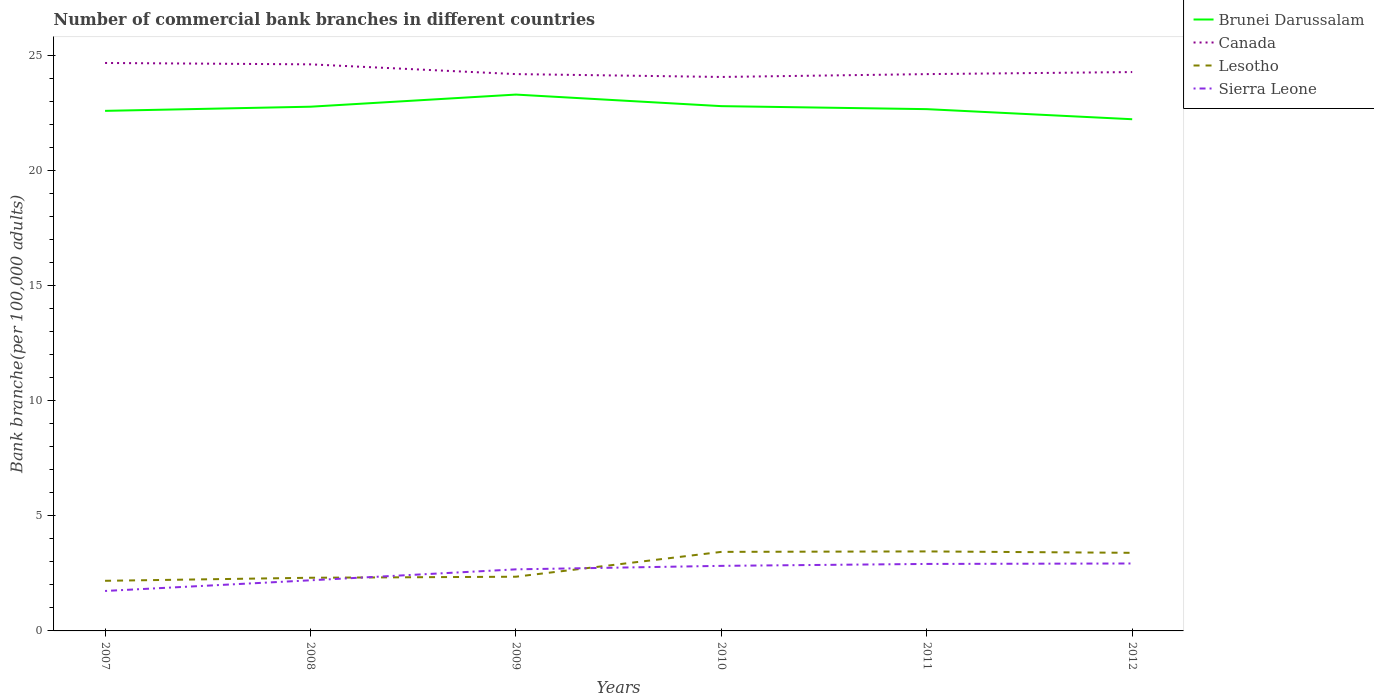Does the line corresponding to Canada intersect with the line corresponding to Sierra Leone?
Your response must be concise. No. Across all years, what is the maximum number of commercial bank branches in Lesotho?
Ensure brevity in your answer.  2.18. What is the total number of commercial bank branches in Canada in the graph?
Your answer should be compact. 0.48. What is the difference between the highest and the second highest number of commercial bank branches in Lesotho?
Provide a short and direct response. 1.28. What is the difference between the highest and the lowest number of commercial bank branches in Sierra Leone?
Offer a terse response. 4. Is the number of commercial bank branches in Sierra Leone strictly greater than the number of commercial bank branches in Canada over the years?
Keep it short and to the point. Yes. How many lines are there?
Offer a very short reply. 4. Does the graph contain grids?
Ensure brevity in your answer.  No. How many legend labels are there?
Provide a short and direct response. 4. What is the title of the graph?
Your answer should be very brief. Number of commercial bank branches in different countries. What is the label or title of the Y-axis?
Keep it short and to the point. Bank branche(per 100,0 adults). What is the Bank branche(per 100,000 adults) of Brunei Darussalam in 2007?
Your response must be concise. 22.58. What is the Bank branche(per 100,000 adults) of Canada in 2007?
Provide a short and direct response. 24.66. What is the Bank branche(per 100,000 adults) in Lesotho in 2007?
Offer a very short reply. 2.18. What is the Bank branche(per 100,000 adults) of Sierra Leone in 2007?
Ensure brevity in your answer.  1.73. What is the Bank branche(per 100,000 adults) in Brunei Darussalam in 2008?
Provide a succinct answer. 22.76. What is the Bank branche(per 100,000 adults) of Canada in 2008?
Your answer should be compact. 24.6. What is the Bank branche(per 100,000 adults) in Lesotho in 2008?
Provide a succinct answer. 2.31. What is the Bank branche(per 100,000 adults) of Sierra Leone in 2008?
Keep it short and to the point. 2.2. What is the Bank branche(per 100,000 adults) of Brunei Darussalam in 2009?
Make the answer very short. 23.29. What is the Bank branche(per 100,000 adults) of Canada in 2009?
Your answer should be compact. 24.18. What is the Bank branche(per 100,000 adults) in Lesotho in 2009?
Offer a very short reply. 2.35. What is the Bank branche(per 100,000 adults) in Sierra Leone in 2009?
Make the answer very short. 2.67. What is the Bank branche(per 100,000 adults) in Brunei Darussalam in 2010?
Keep it short and to the point. 22.79. What is the Bank branche(per 100,000 adults) in Canada in 2010?
Provide a short and direct response. 24.05. What is the Bank branche(per 100,000 adults) in Lesotho in 2010?
Your response must be concise. 3.43. What is the Bank branche(per 100,000 adults) of Sierra Leone in 2010?
Offer a very short reply. 2.83. What is the Bank branche(per 100,000 adults) of Brunei Darussalam in 2011?
Keep it short and to the point. 22.66. What is the Bank branche(per 100,000 adults) in Canada in 2011?
Your answer should be compact. 24.18. What is the Bank branche(per 100,000 adults) in Lesotho in 2011?
Your answer should be very brief. 3.45. What is the Bank branche(per 100,000 adults) in Sierra Leone in 2011?
Provide a short and direct response. 2.91. What is the Bank branche(per 100,000 adults) of Brunei Darussalam in 2012?
Your answer should be compact. 22.22. What is the Bank branche(per 100,000 adults) of Canada in 2012?
Provide a short and direct response. 24.27. What is the Bank branche(per 100,000 adults) of Lesotho in 2012?
Ensure brevity in your answer.  3.39. What is the Bank branche(per 100,000 adults) of Sierra Leone in 2012?
Keep it short and to the point. 2.93. Across all years, what is the maximum Bank branche(per 100,000 adults) in Brunei Darussalam?
Your answer should be compact. 23.29. Across all years, what is the maximum Bank branche(per 100,000 adults) in Canada?
Provide a short and direct response. 24.66. Across all years, what is the maximum Bank branche(per 100,000 adults) in Lesotho?
Your answer should be very brief. 3.45. Across all years, what is the maximum Bank branche(per 100,000 adults) in Sierra Leone?
Your answer should be compact. 2.93. Across all years, what is the minimum Bank branche(per 100,000 adults) in Brunei Darussalam?
Offer a very short reply. 22.22. Across all years, what is the minimum Bank branche(per 100,000 adults) in Canada?
Give a very brief answer. 24.05. Across all years, what is the minimum Bank branche(per 100,000 adults) of Lesotho?
Provide a succinct answer. 2.18. Across all years, what is the minimum Bank branche(per 100,000 adults) in Sierra Leone?
Offer a terse response. 1.73. What is the total Bank branche(per 100,000 adults) of Brunei Darussalam in the graph?
Ensure brevity in your answer.  136.29. What is the total Bank branche(per 100,000 adults) in Canada in the graph?
Your answer should be very brief. 145.93. What is the total Bank branche(per 100,000 adults) in Lesotho in the graph?
Offer a very short reply. 17.11. What is the total Bank branche(per 100,000 adults) of Sierra Leone in the graph?
Keep it short and to the point. 15.27. What is the difference between the Bank branche(per 100,000 adults) in Brunei Darussalam in 2007 and that in 2008?
Offer a terse response. -0.18. What is the difference between the Bank branche(per 100,000 adults) in Canada in 2007 and that in 2008?
Keep it short and to the point. 0.06. What is the difference between the Bank branche(per 100,000 adults) of Lesotho in 2007 and that in 2008?
Provide a short and direct response. -0.13. What is the difference between the Bank branche(per 100,000 adults) in Sierra Leone in 2007 and that in 2008?
Offer a terse response. -0.46. What is the difference between the Bank branche(per 100,000 adults) in Brunei Darussalam in 2007 and that in 2009?
Give a very brief answer. -0.71. What is the difference between the Bank branche(per 100,000 adults) in Canada in 2007 and that in 2009?
Provide a succinct answer. 0.48. What is the difference between the Bank branche(per 100,000 adults) in Lesotho in 2007 and that in 2009?
Offer a very short reply. -0.18. What is the difference between the Bank branche(per 100,000 adults) in Sierra Leone in 2007 and that in 2009?
Make the answer very short. -0.94. What is the difference between the Bank branche(per 100,000 adults) in Brunei Darussalam in 2007 and that in 2010?
Offer a very short reply. -0.2. What is the difference between the Bank branche(per 100,000 adults) of Canada in 2007 and that in 2010?
Offer a terse response. 0.61. What is the difference between the Bank branche(per 100,000 adults) of Lesotho in 2007 and that in 2010?
Offer a very short reply. -1.26. What is the difference between the Bank branche(per 100,000 adults) of Sierra Leone in 2007 and that in 2010?
Provide a short and direct response. -1.09. What is the difference between the Bank branche(per 100,000 adults) in Brunei Darussalam in 2007 and that in 2011?
Your answer should be very brief. -0.07. What is the difference between the Bank branche(per 100,000 adults) in Canada in 2007 and that in 2011?
Keep it short and to the point. 0.48. What is the difference between the Bank branche(per 100,000 adults) of Lesotho in 2007 and that in 2011?
Your answer should be compact. -1.28. What is the difference between the Bank branche(per 100,000 adults) of Sierra Leone in 2007 and that in 2011?
Your answer should be compact. -1.17. What is the difference between the Bank branche(per 100,000 adults) in Brunei Darussalam in 2007 and that in 2012?
Offer a very short reply. 0.36. What is the difference between the Bank branche(per 100,000 adults) of Canada in 2007 and that in 2012?
Give a very brief answer. 0.39. What is the difference between the Bank branche(per 100,000 adults) of Lesotho in 2007 and that in 2012?
Keep it short and to the point. -1.21. What is the difference between the Bank branche(per 100,000 adults) of Sierra Leone in 2007 and that in 2012?
Give a very brief answer. -1.19. What is the difference between the Bank branche(per 100,000 adults) in Brunei Darussalam in 2008 and that in 2009?
Ensure brevity in your answer.  -0.53. What is the difference between the Bank branche(per 100,000 adults) in Canada in 2008 and that in 2009?
Provide a short and direct response. 0.42. What is the difference between the Bank branche(per 100,000 adults) in Lesotho in 2008 and that in 2009?
Ensure brevity in your answer.  -0.04. What is the difference between the Bank branche(per 100,000 adults) of Sierra Leone in 2008 and that in 2009?
Provide a short and direct response. -0.48. What is the difference between the Bank branche(per 100,000 adults) of Brunei Darussalam in 2008 and that in 2010?
Your answer should be compact. -0.02. What is the difference between the Bank branche(per 100,000 adults) in Canada in 2008 and that in 2010?
Offer a very short reply. 0.55. What is the difference between the Bank branche(per 100,000 adults) of Lesotho in 2008 and that in 2010?
Provide a short and direct response. -1.12. What is the difference between the Bank branche(per 100,000 adults) of Sierra Leone in 2008 and that in 2010?
Provide a succinct answer. -0.63. What is the difference between the Bank branche(per 100,000 adults) of Brunei Darussalam in 2008 and that in 2011?
Provide a succinct answer. 0.11. What is the difference between the Bank branche(per 100,000 adults) of Canada in 2008 and that in 2011?
Provide a succinct answer. 0.42. What is the difference between the Bank branche(per 100,000 adults) in Lesotho in 2008 and that in 2011?
Your answer should be compact. -1.14. What is the difference between the Bank branche(per 100,000 adults) of Sierra Leone in 2008 and that in 2011?
Provide a succinct answer. -0.71. What is the difference between the Bank branche(per 100,000 adults) of Brunei Darussalam in 2008 and that in 2012?
Make the answer very short. 0.54. What is the difference between the Bank branche(per 100,000 adults) of Canada in 2008 and that in 2012?
Provide a short and direct response. 0.34. What is the difference between the Bank branche(per 100,000 adults) of Lesotho in 2008 and that in 2012?
Ensure brevity in your answer.  -1.08. What is the difference between the Bank branche(per 100,000 adults) in Sierra Leone in 2008 and that in 2012?
Offer a terse response. -0.73. What is the difference between the Bank branche(per 100,000 adults) in Brunei Darussalam in 2009 and that in 2010?
Your answer should be compact. 0.5. What is the difference between the Bank branche(per 100,000 adults) in Canada in 2009 and that in 2010?
Keep it short and to the point. 0.12. What is the difference between the Bank branche(per 100,000 adults) in Lesotho in 2009 and that in 2010?
Ensure brevity in your answer.  -1.08. What is the difference between the Bank branche(per 100,000 adults) in Sierra Leone in 2009 and that in 2010?
Give a very brief answer. -0.15. What is the difference between the Bank branche(per 100,000 adults) in Brunei Darussalam in 2009 and that in 2011?
Your answer should be compact. 0.63. What is the difference between the Bank branche(per 100,000 adults) of Lesotho in 2009 and that in 2011?
Keep it short and to the point. -1.1. What is the difference between the Bank branche(per 100,000 adults) in Sierra Leone in 2009 and that in 2011?
Your response must be concise. -0.23. What is the difference between the Bank branche(per 100,000 adults) in Brunei Darussalam in 2009 and that in 2012?
Your response must be concise. 1.07. What is the difference between the Bank branche(per 100,000 adults) of Canada in 2009 and that in 2012?
Make the answer very short. -0.09. What is the difference between the Bank branche(per 100,000 adults) in Lesotho in 2009 and that in 2012?
Provide a short and direct response. -1.04. What is the difference between the Bank branche(per 100,000 adults) of Sierra Leone in 2009 and that in 2012?
Make the answer very short. -0.25. What is the difference between the Bank branche(per 100,000 adults) of Brunei Darussalam in 2010 and that in 2011?
Your response must be concise. 0.13. What is the difference between the Bank branche(per 100,000 adults) in Canada in 2010 and that in 2011?
Give a very brief answer. -0.12. What is the difference between the Bank branche(per 100,000 adults) of Lesotho in 2010 and that in 2011?
Provide a short and direct response. -0.02. What is the difference between the Bank branche(per 100,000 adults) of Sierra Leone in 2010 and that in 2011?
Keep it short and to the point. -0.08. What is the difference between the Bank branche(per 100,000 adults) of Brunei Darussalam in 2010 and that in 2012?
Your answer should be very brief. 0.57. What is the difference between the Bank branche(per 100,000 adults) of Canada in 2010 and that in 2012?
Ensure brevity in your answer.  -0.21. What is the difference between the Bank branche(per 100,000 adults) of Lesotho in 2010 and that in 2012?
Provide a succinct answer. 0.04. What is the difference between the Bank branche(per 100,000 adults) in Sierra Leone in 2010 and that in 2012?
Provide a succinct answer. -0.1. What is the difference between the Bank branche(per 100,000 adults) of Brunei Darussalam in 2011 and that in 2012?
Your answer should be very brief. 0.44. What is the difference between the Bank branche(per 100,000 adults) in Canada in 2011 and that in 2012?
Keep it short and to the point. -0.09. What is the difference between the Bank branche(per 100,000 adults) of Lesotho in 2011 and that in 2012?
Provide a short and direct response. 0.06. What is the difference between the Bank branche(per 100,000 adults) of Sierra Leone in 2011 and that in 2012?
Your response must be concise. -0.02. What is the difference between the Bank branche(per 100,000 adults) in Brunei Darussalam in 2007 and the Bank branche(per 100,000 adults) in Canada in 2008?
Your response must be concise. -2.02. What is the difference between the Bank branche(per 100,000 adults) in Brunei Darussalam in 2007 and the Bank branche(per 100,000 adults) in Lesotho in 2008?
Offer a very short reply. 20.27. What is the difference between the Bank branche(per 100,000 adults) in Brunei Darussalam in 2007 and the Bank branche(per 100,000 adults) in Sierra Leone in 2008?
Offer a terse response. 20.38. What is the difference between the Bank branche(per 100,000 adults) in Canada in 2007 and the Bank branche(per 100,000 adults) in Lesotho in 2008?
Make the answer very short. 22.35. What is the difference between the Bank branche(per 100,000 adults) of Canada in 2007 and the Bank branche(per 100,000 adults) of Sierra Leone in 2008?
Your answer should be compact. 22.46. What is the difference between the Bank branche(per 100,000 adults) of Lesotho in 2007 and the Bank branche(per 100,000 adults) of Sierra Leone in 2008?
Ensure brevity in your answer.  -0.02. What is the difference between the Bank branche(per 100,000 adults) in Brunei Darussalam in 2007 and the Bank branche(per 100,000 adults) in Canada in 2009?
Your answer should be compact. -1.6. What is the difference between the Bank branche(per 100,000 adults) of Brunei Darussalam in 2007 and the Bank branche(per 100,000 adults) of Lesotho in 2009?
Your response must be concise. 20.23. What is the difference between the Bank branche(per 100,000 adults) of Brunei Darussalam in 2007 and the Bank branche(per 100,000 adults) of Sierra Leone in 2009?
Provide a succinct answer. 19.91. What is the difference between the Bank branche(per 100,000 adults) in Canada in 2007 and the Bank branche(per 100,000 adults) in Lesotho in 2009?
Your response must be concise. 22.31. What is the difference between the Bank branche(per 100,000 adults) in Canada in 2007 and the Bank branche(per 100,000 adults) in Sierra Leone in 2009?
Provide a short and direct response. 21.99. What is the difference between the Bank branche(per 100,000 adults) of Lesotho in 2007 and the Bank branche(per 100,000 adults) of Sierra Leone in 2009?
Your answer should be very brief. -0.5. What is the difference between the Bank branche(per 100,000 adults) of Brunei Darussalam in 2007 and the Bank branche(per 100,000 adults) of Canada in 2010?
Keep it short and to the point. -1.47. What is the difference between the Bank branche(per 100,000 adults) of Brunei Darussalam in 2007 and the Bank branche(per 100,000 adults) of Lesotho in 2010?
Your answer should be very brief. 19.15. What is the difference between the Bank branche(per 100,000 adults) of Brunei Darussalam in 2007 and the Bank branche(per 100,000 adults) of Sierra Leone in 2010?
Provide a short and direct response. 19.76. What is the difference between the Bank branche(per 100,000 adults) in Canada in 2007 and the Bank branche(per 100,000 adults) in Lesotho in 2010?
Offer a very short reply. 21.23. What is the difference between the Bank branche(per 100,000 adults) of Canada in 2007 and the Bank branche(per 100,000 adults) of Sierra Leone in 2010?
Provide a short and direct response. 21.83. What is the difference between the Bank branche(per 100,000 adults) in Lesotho in 2007 and the Bank branche(per 100,000 adults) in Sierra Leone in 2010?
Keep it short and to the point. -0.65. What is the difference between the Bank branche(per 100,000 adults) in Brunei Darussalam in 2007 and the Bank branche(per 100,000 adults) in Canada in 2011?
Your response must be concise. -1.6. What is the difference between the Bank branche(per 100,000 adults) in Brunei Darussalam in 2007 and the Bank branche(per 100,000 adults) in Lesotho in 2011?
Offer a very short reply. 19.13. What is the difference between the Bank branche(per 100,000 adults) of Brunei Darussalam in 2007 and the Bank branche(per 100,000 adults) of Sierra Leone in 2011?
Your response must be concise. 19.67. What is the difference between the Bank branche(per 100,000 adults) of Canada in 2007 and the Bank branche(per 100,000 adults) of Lesotho in 2011?
Ensure brevity in your answer.  21.21. What is the difference between the Bank branche(per 100,000 adults) in Canada in 2007 and the Bank branche(per 100,000 adults) in Sierra Leone in 2011?
Your answer should be very brief. 21.75. What is the difference between the Bank branche(per 100,000 adults) in Lesotho in 2007 and the Bank branche(per 100,000 adults) in Sierra Leone in 2011?
Give a very brief answer. -0.73. What is the difference between the Bank branche(per 100,000 adults) of Brunei Darussalam in 2007 and the Bank branche(per 100,000 adults) of Canada in 2012?
Your answer should be very brief. -1.68. What is the difference between the Bank branche(per 100,000 adults) of Brunei Darussalam in 2007 and the Bank branche(per 100,000 adults) of Lesotho in 2012?
Offer a terse response. 19.19. What is the difference between the Bank branche(per 100,000 adults) of Brunei Darussalam in 2007 and the Bank branche(per 100,000 adults) of Sierra Leone in 2012?
Provide a succinct answer. 19.65. What is the difference between the Bank branche(per 100,000 adults) in Canada in 2007 and the Bank branche(per 100,000 adults) in Lesotho in 2012?
Give a very brief answer. 21.27. What is the difference between the Bank branche(per 100,000 adults) of Canada in 2007 and the Bank branche(per 100,000 adults) of Sierra Leone in 2012?
Offer a terse response. 21.73. What is the difference between the Bank branche(per 100,000 adults) of Lesotho in 2007 and the Bank branche(per 100,000 adults) of Sierra Leone in 2012?
Give a very brief answer. -0.75. What is the difference between the Bank branche(per 100,000 adults) in Brunei Darussalam in 2008 and the Bank branche(per 100,000 adults) in Canada in 2009?
Your answer should be very brief. -1.42. What is the difference between the Bank branche(per 100,000 adults) in Brunei Darussalam in 2008 and the Bank branche(per 100,000 adults) in Lesotho in 2009?
Offer a terse response. 20.41. What is the difference between the Bank branche(per 100,000 adults) in Brunei Darussalam in 2008 and the Bank branche(per 100,000 adults) in Sierra Leone in 2009?
Make the answer very short. 20.09. What is the difference between the Bank branche(per 100,000 adults) of Canada in 2008 and the Bank branche(per 100,000 adults) of Lesotho in 2009?
Provide a short and direct response. 22.25. What is the difference between the Bank branche(per 100,000 adults) of Canada in 2008 and the Bank branche(per 100,000 adults) of Sierra Leone in 2009?
Give a very brief answer. 21.93. What is the difference between the Bank branche(per 100,000 adults) in Lesotho in 2008 and the Bank branche(per 100,000 adults) in Sierra Leone in 2009?
Your answer should be compact. -0.37. What is the difference between the Bank branche(per 100,000 adults) of Brunei Darussalam in 2008 and the Bank branche(per 100,000 adults) of Canada in 2010?
Ensure brevity in your answer.  -1.29. What is the difference between the Bank branche(per 100,000 adults) in Brunei Darussalam in 2008 and the Bank branche(per 100,000 adults) in Lesotho in 2010?
Keep it short and to the point. 19.33. What is the difference between the Bank branche(per 100,000 adults) of Brunei Darussalam in 2008 and the Bank branche(per 100,000 adults) of Sierra Leone in 2010?
Keep it short and to the point. 19.94. What is the difference between the Bank branche(per 100,000 adults) in Canada in 2008 and the Bank branche(per 100,000 adults) in Lesotho in 2010?
Offer a very short reply. 21.17. What is the difference between the Bank branche(per 100,000 adults) of Canada in 2008 and the Bank branche(per 100,000 adults) of Sierra Leone in 2010?
Your answer should be very brief. 21.78. What is the difference between the Bank branche(per 100,000 adults) in Lesotho in 2008 and the Bank branche(per 100,000 adults) in Sierra Leone in 2010?
Your answer should be compact. -0.52. What is the difference between the Bank branche(per 100,000 adults) of Brunei Darussalam in 2008 and the Bank branche(per 100,000 adults) of Canada in 2011?
Ensure brevity in your answer.  -1.42. What is the difference between the Bank branche(per 100,000 adults) in Brunei Darussalam in 2008 and the Bank branche(per 100,000 adults) in Lesotho in 2011?
Offer a terse response. 19.31. What is the difference between the Bank branche(per 100,000 adults) in Brunei Darussalam in 2008 and the Bank branche(per 100,000 adults) in Sierra Leone in 2011?
Your answer should be compact. 19.85. What is the difference between the Bank branche(per 100,000 adults) in Canada in 2008 and the Bank branche(per 100,000 adults) in Lesotho in 2011?
Your response must be concise. 21.15. What is the difference between the Bank branche(per 100,000 adults) of Canada in 2008 and the Bank branche(per 100,000 adults) of Sierra Leone in 2011?
Ensure brevity in your answer.  21.69. What is the difference between the Bank branche(per 100,000 adults) of Lesotho in 2008 and the Bank branche(per 100,000 adults) of Sierra Leone in 2011?
Make the answer very short. -0.6. What is the difference between the Bank branche(per 100,000 adults) in Brunei Darussalam in 2008 and the Bank branche(per 100,000 adults) in Canada in 2012?
Your answer should be compact. -1.5. What is the difference between the Bank branche(per 100,000 adults) in Brunei Darussalam in 2008 and the Bank branche(per 100,000 adults) in Lesotho in 2012?
Offer a very short reply. 19.37. What is the difference between the Bank branche(per 100,000 adults) of Brunei Darussalam in 2008 and the Bank branche(per 100,000 adults) of Sierra Leone in 2012?
Give a very brief answer. 19.83. What is the difference between the Bank branche(per 100,000 adults) of Canada in 2008 and the Bank branche(per 100,000 adults) of Lesotho in 2012?
Keep it short and to the point. 21.21. What is the difference between the Bank branche(per 100,000 adults) in Canada in 2008 and the Bank branche(per 100,000 adults) in Sierra Leone in 2012?
Ensure brevity in your answer.  21.67. What is the difference between the Bank branche(per 100,000 adults) in Lesotho in 2008 and the Bank branche(per 100,000 adults) in Sierra Leone in 2012?
Your response must be concise. -0.62. What is the difference between the Bank branche(per 100,000 adults) in Brunei Darussalam in 2009 and the Bank branche(per 100,000 adults) in Canada in 2010?
Offer a very short reply. -0.77. What is the difference between the Bank branche(per 100,000 adults) of Brunei Darussalam in 2009 and the Bank branche(per 100,000 adults) of Lesotho in 2010?
Make the answer very short. 19.86. What is the difference between the Bank branche(per 100,000 adults) in Brunei Darussalam in 2009 and the Bank branche(per 100,000 adults) in Sierra Leone in 2010?
Provide a short and direct response. 20.46. What is the difference between the Bank branche(per 100,000 adults) in Canada in 2009 and the Bank branche(per 100,000 adults) in Lesotho in 2010?
Ensure brevity in your answer.  20.74. What is the difference between the Bank branche(per 100,000 adults) in Canada in 2009 and the Bank branche(per 100,000 adults) in Sierra Leone in 2010?
Ensure brevity in your answer.  21.35. What is the difference between the Bank branche(per 100,000 adults) of Lesotho in 2009 and the Bank branche(per 100,000 adults) of Sierra Leone in 2010?
Offer a terse response. -0.47. What is the difference between the Bank branche(per 100,000 adults) in Brunei Darussalam in 2009 and the Bank branche(per 100,000 adults) in Canada in 2011?
Give a very brief answer. -0.89. What is the difference between the Bank branche(per 100,000 adults) in Brunei Darussalam in 2009 and the Bank branche(per 100,000 adults) in Lesotho in 2011?
Offer a terse response. 19.84. What is the difference between the Bank branche(per 100,000 adults) of Brunei Darussalam in 2009 and the Bank branche(per 100,000 adults) of Sierra Leone in 2011?
Ensure brevity in your answer.  20.38. What is the difference between the Bank branche(per 100,000 adults) in Canada in 2009 and the Bank branche(per 100,000 adults) in Lesotho in 2011?
Ensure brevity in your answer.  20.72. What is the difference between the Bank branche(per 100,000 adults) in Canada in 2009 and the Bank branche(per 100,000 adults) in Sierra Leone in 2011?
Your response must be concise. 21.27. What is the difference between the Bank branche(per 100,000 adults) of Lesotho in 2009 and the Bank branche(per 100,000 adults) of Sierra Leone in 2011?
Offer a terse response. -0.55. What is the difference between the Bank branche(per 100,000 adults) in Brunei Darussalam in 2009 and the Bank branche(per 100,000 adults) in Canada in 2012?
Ensure brevity in your answer.  -0.98. What is the difference between the Bank branche(per 100,000 adults) in Brunei Darussalam in 2009 and the Bank branche(per 100,000 adults) in Lesotho in 2012?
Offer a terse response. 19.9. What is the difference between the Bank branche(per 100,000 adults) of Brunei Darussalam in 2009 and the Bank branche(per 100,000 adults) of Sierra Leone in 2012?
Ensure brevity in your answer.  20.36. What is the difference between the Bank branche(per 100,000 adults) of Canada in 2009 and the Bank branche(per 100,000 adults) of Lesotho in 2012?
Your answer should be very brief. 20.79. What is the difference between the Bank branche(per 100,000 adults) in Canada in 2009 and the Bank branche(per 100,000 adults) in Sierra Leone in 2012?
Offer a terse response. 21.25. What is the difference between the Bank branche(per 100,000 adults) of Lesotho in 2009 and the Bank branche(per 100,000 adults) of Sierra Leone in 2012?
Ensure brevity in your answer.  -0.57. What is the difference between the Bank branche(per 100,000 adults) of Brunei Darussalam in 2010 and the Bank branche(per 100,000 adults) of Canada in 2011?
Your answer should be very brief. -1.39. What is the difference between the Bank branche(per 100,000 adults) of Brunei Darussalam in 2010 and the Bank branche(per 100,000 adults) of Lesotho in 2011?
Your answer should be very brief. 19.33. What is the difference between the Bank branche(per 100,000 adults) in Brunei Darussalam in 2010 and the Bank branche(per 100,000 adults) in Sierra Leone in 2011?
Your answer should be very brief. 19.88. What is the difference between the Bank branche(per 100,000 adults) of Canada in 2010 and the Bank branche(per 100,000 adults) of Lesotho in 2011?
Make the answer very short. 20.6. What is the difference between the Bank branche(per 100,000 adults) of Canada in 2010 and the Bank branche(per 100,000 adults) of Sierra Leone in 2011?
Your response must be concise. 21.14. What is the difference between the Bank branche(per 100,000 adults) in Lesotho in 2010 and the Bank branche(per 100,000 adults) in Sierra Leone in 2011?
Provide a short and direct response. 0.52. What is the difference between the Bank branche(per 100,000 adults) in Brunei Darussalam in 2010 and the Bank branche(per 100,000 adults) in Canada in 2012?
Give a very brief answer. -1.48. What is the difference between the Bank branche(per 100,000 adults) of Brunei Darussalam in 2010 and the Bank branche(per 100,000 adults) of Lesotho in 2012?
Offer a very short reply. 19.39. What is the difference between the Bank branche(per 100,000 adults) of Brunei Darussalam in 2010 and the Bank branche(per 100,000 adults) of Sierra Leone in 2012?
Your response must be concise. 19.86. What is the difference between the Bank branche(per 100,000 adults) of Canada in 2010 and the Bank branche(per 100,000 adults) of Lesotho in 2012?
Provide a short and direct response. 20.66. What is the difference between the Bank branche(per 100,000 adults) of Canada in 2010 and the Bank branche(per 100,000 adults) of Sierra Leone in 2012?
Offer a very short reply. 21.12. What is the difference between the Bank branche(per 100,000 adults) of Lesotho in 2010 and the Bank branche(per 100,000 adults) of Sierra Leone in 2012?
Give a very brief answer. 0.5. What is the difference between the Bank branche(per 100,000 adults) of Brunei Darussalam in 2011 and the Bank branche(per 100,000 adults) of Canada in 2012?
Offer a terse response. -1.61. What is the difference between the Bank branche(per 100,000 adults) in Brunei Darussalam in 2011 and the Bank branche(per 100,000 adults) in Lesotho in 2012?
Offer a very short reply. 19.26. What is the difference between the Bank branche(per 100,000 adults) of Brunei Darussalam in 2011 and the Bank branche(per 100,000 adults) of Sierra Leone in 2012?
Keep it short and to the point. 19.73. What is the difference between the Bank branche(per 100,000 adults) in Canada in 2011 and the Bank branche(per 100,000 adults) in Lesotho in 2012?
Provide a succinct answer. 20.79. What is the difference between the Bank branche(per 100,000 adults) of Canada in 2011 and the Bank branche(per 100,000 adults) of Sierra Leone in 2012?
Make the answer very short. 21.25. What is the difference between the Bank branche(per 100,000 adults) in Lesotho in 2011 and the Bank branche(per 100,000 adults) in Sierra Leone in 2012?
Your answer should be compact. 0.52. What is the average Bank branche(per 100,000 adults) in Brunei Darussalam per year?
Offer a terse response. 22.71. What is the average Bank branche(per 100,000 adults) of Canada per year?
Your answer should be very brief. 24.32. What is the average Bank branche(per 100,000 adults) in Lesotho per year?
Offer a very short reply. 2.85. What is the average Bank branche(per 100,000 adults) in Sierra Leone per year?
Your answer should be compact. 2.54. In the year 2007, what is the difference between the Bank branche(per 100,000 adults) in Brunei Darussalam and Bank branche(per 100,000 adults) in Canada?
Your answer should be compact. -2.08. In the year 2007, what is the difference between the Bank branche(per 100,000 adults) of Brunei Darussalam and Bank branche(per 100,000 adults) of Lesotho?
Provide a short and direct response. 20.4. In the year 2007, what is the difference between the Bank branche(per 100,000 adults) of Brunei Darussalam and Bank branche(per 100,000 adults) of Sierra Leone?
Your answer should be compact. 20.85. In the year 2007, what is the difference between the Bank branche(per 100,000 adults) of Canada and Bank branche(per 100,000 adults) of Lesotho?
Ensure brevity in your answer.  22.48. In the year 2007, what is the difference between the Bank branche(per 100,000 adults) of Canada and Bank branche(per 100,000 adults) of Sierra Leone?
Ensure brevity in your answer.  22.92. In the year 2007, what is the difference between the Bank branche(per 100,000 adults) in Lesotho and Bank branche(per 100,000 adults) in Sierra Leone?
Your answer should be compact. 0.44. In the year 2008, what is the difference between the Bank branche(per 100,000 adults) in Brunei Darussalam and Bank branche(per 100,000 adults) in Canada?
Offer a very short reply. -1.84. In the year 2008, what is the difference between the Bank branche(per 100,000 adults) in Brunei Darussalam and Bank branche(per 100,000 adults) in Lesotho?
Provide a succinct answer. 20.45. In the year 2008, what is the difference between the Bank branche(per 100,000 adults) in Brunei Darussalam and Bank branche(per 100,000 adults) in Sierra Leone?
Offer a terse response. 20.56. In the year 2008, what is the difference between the Bank branche(per 100,000 adults) in Canada and Bank branche(per 100,000 adults) in Lesotho?
Make the answer very short. 22.29. In the year 2008, what is the difference between the Bank branche(per 100,000 adults) of Canada and Bank branche(per 100,000 adults) of Sierra Leone?
Your answer should be compact. 22.4. In the year 2008, what is the difference between the Bank branche(per 100,000 adults) of Lesotho and Bank branche(per 100,000 adults) of Sierra Leone?
Offer a very short reply. 0.11. In the year 2009, what is the difference between the Bank branche(per 100,000 adults) of Brunei Darussalam and Bank branche(per 100,000 adults) of Canada?
Provide a succinct answer. -0.89. In the year 2009, what is the difference between the Bank branche(per 100,000 adults) of Brunei Darussalam and Bank branche(per 100,000 adults) of Lesotho?
Make the answer very short. 20.93. In the year 2009, what is the difference between the Bank branche(per 100,000 adults) in Brunei Darussalam and Bank branche(per 100,000 adults) in Sierra Leone?
Your answer should be very brief. 20.61. In the year 2009, what is the difference between the Bank branche(per 100,000 adults) in Canada and Bank branche(per 100,000 adults) in Lesotho?
Offer a terse response. 21.82. In the year 2009, what is the difference between the Bank branche(per 100,000 adults) in Canada and Bank branche(per 100,000 adults) in Sierra Leone?
Your response must be concise. 21.5. In the year 2009, what is the difference between the Bank branche(per 100,000 adults) of Lesotho and Bank branche(per 100,000 adults) of Sierra Leone?
Your answer should be compact. -0.32. In the year 2010, what is the difference between the Bank branche(per 100,000 adults) in Brunei Darussalam and Bank branche(per 100,000 adults) in Canada?
Provide a short and direct response. -1.27. In the year 2010, what is the difference between the Bank branche(per 100,000 adults) in Brunei Darussalam and Bank branche(per 100,000 adults) in Lesotho?
Offer a terse response. 19.35. In the year 2010, what is the difference between the Bank branche(per 100,000 adults) of Brunei Darussalam and Bank branche(per 100,000 adults) of Sierra Leone?
Your response must be concise. 19.96. In the year 2010, what is the difference between the Bank branche(per 100,000 adults) of Canada and Bank branche(per 100,000 adults) of Lesotho?
Provide a short and direct response. 20.62. In the year 2010, what is the difference between the Bank branche(per 100,000 adults) of Canada and Bank branche(per 100,000 adults) of Sierra Leone?
Offer a terse response. 21.23. In the year 2010, what is the difference between the Bank branche(per 100,000 adults) of Lesotho and Bank branche(per 100,000 adults) of Sierra Leone?
Provide a succinct answer. 0.61. In the year 2011, what is the difference between the Bank branche(per 100,000 adults) in Brunei Darussalam and Bank branche(per 100,000 adults) in Canada?
Provide a short and direct response. -1.52. In the year 2011, what is the difference between the Bank branche(per 100,000 adults) in Brunei Darussalam and Bank branche(per 100,000 adults) in Lesotho?
Give a very brief answer. 19.2. In the year 2011, what is the difference between the Bank branche(per 100,000 adults) of Brunei Darussalam and Bank branche(per 100,000 adults) of Sierra Leone?
Ensure brevity in your answer.  19.75. In the year 2011, what is the difference between the Bank branche(per 100,000 adults) in Canada and Bank branche(per 100,000 adults) in Lesotho?
Your answer should be compact. 20.72. In the year 2011, what is the difference between the Bank branche(per 100,000 adults) in Canada and Bank branche(per 100,000 adults) in Sierra Leone?
Your answer should be very brief. 21.27. In the year 2011, what is the difference between the Bank branche(per 100,000 adults) in Lesotho and Bank branche(per 100,000 adults) in Sierra Leone?
Keep it short and to the point. 0.54. In the year 2012, what is the difference between the Bank branche(per 100,000 adults) of Brunei Darussalam and Bank branche(per 100,000 adults) of Canada?
Offer a very short reply. -2.05. In the year 2012, what is the difference between the Bank branche(per 100,000 adults) of Brunei Darussalam and Bank branche(per 100,000 adults) of Lesotho?
Offer a very short reply. 18.83. In the year 2012, what is the difference between the Bank branche(per 100,000 adults) of Brunei Darussalam and Bank branche(per 100,000 adults) of Sierra Leone?
Provide a short and direct response. 19.29. In the year 2012, what is the difference between the Bank branche(per 100,000 adults) of Canada and Bank branche(per 100,000 adults) of Lesotho?
Offer a terse response. 20.87. In the year 2012, what is the difference between the Bank branche(per 100,000 adults) of Canada and Bank branche(per 100,000 adults) of Sierra Leone?
Your answer should be very brief. 21.34. In the year 2012, what is the difference between the Bank branche(per 100,000 adults) in Lesotho and Bank branche(per 100,000 adults) in Sierra Leone?
Make the answer very short. 0.46. What is the ratio of the Bank branche(per 100,000 adults) of Brunei Darussalam in 2007 to that in 2008?
Offer a very short reply. 0.99. What is the ratio of the Bank branche(per 100,000 adults) of Canada in 2007 to that in 2008?
Offer a very short reply. 1. What is the ratio of the Bank branche(per 100,000 adults) of Lesotho in 2007 to that in 2008?
Give a very brief answer. 0.94. What is the ratio of the Bank branche(per 100,000 adults) of Sierra Leone in 2007 to that in 2008?
Provide a short and direct response. 0.79. What is the ratio of the Bank branche(per 100,000 adults) in Brunei Darussalam in 2007 to that in 2009?
Make the answer very short. 0.97. What is the ratio of the Bank branche(per 100,000 adults) of Lesotho in 2007 to that in 2009?
Offer a terse response. 0.92. What is the ratio of the Bank branche(per 100,000 adults) of Sierra Leone in 2007 to that in 2009?
Keep it short and to the point. 0.65. What is the ratio of the Bank branche(per 100,000 adults) in Canada in 2007 to that in 2010?
Your response must be concise. 1.03. What is the ratio of the Bank branche(per 100,000 adults) in Lesotho in 2007 to that in 2010?
Offer a very short reply. 0.63. What is the ratio of the Bank branche(per 100,000 adults) in Sierra Leone in 2007 to that in 2010?
Offer a terse response. 0.61. What is the ratio of the Bank branche(per 100,000 adults) of Lesotho in 2007 to that in 2011?
Your answer should be compact. 0.63. What is the ratio of the Bank branche(per 100,000 adults) in Sierra Leone in 2007 to that in 2011?
Give a very brief answer. 0.6. What is the ratio of the Bank branche(per 100,000 adults) in Brunei Darussalam in 2007 to that in 2012?
Your answer should be very brief. 1.02. What is the ratio of the Bank branche(per 100,000 adults) of Canada in 2007 to that in 2012?
Make the answer very short. 1.02. What is the ratio of the Bank branche(per 100,000 adults) of Lesotho in 2007 to that in 2012?
Make the answer very short. 0.64. What is the ratio of the Bank branche(per 100,000 adults) of Sierra Leone in 2007 to that in 2012?
Make the answer very short. 0.59. What is the ratio of the Bank branche(per 100,000 adults) of Brunei Darussalam in 2008 to that in 2009?
Your response must be concise. 0.98. What is the ratio of the Bank branche(per 100,000 adults) in Canada in 2008 to that in 2009?
Make the answer very short. 1.02. What is the ratio of the Bank branche(per 100,000 adults) in Lesotho in 2008 to that in 2009?
Provide a short and direct response. 0.98. What is the ratio of the Bank branche(per 100,000 adults) of Sierra Leone in 2008 to that in 2009?
Offer a terse response. 0.82. What is the ratio of the Bank branche(per 100,000 adults) in Brunei Darussalam in 2008 to that in 2010?
Keep it short and to the point. 1. What is the ratio of the Bank branche(per 100,000 adults) of Canada in 2008 to that in 2010?
Your response must be concise. 1.02. What is the ratio of the Bank branche(per 100,000 adults) of Lesotho in 2008 to that in 2010?
Ensure brevity in your answer.  0.67. What is the ratio of the Bank branche(per 100,000 adults) in Sierra Leone in 2008 to that in 2010?
Ensure brevity in your answer.  0.78. What is the ratio of the Bank branche(per 100,000 adults) of Canada in 2008 to that in 2011?
Offer a very short reply. 1.02. What is the ratio of the Bank branche(per 100,000 adults) in Lesotho in 2008 to that in 2011?
Your answer should be compact. 0.67. What is the ratio of the Bank branche(per 100,000 adults) of Sierra Leone in 2008 to that in 2011?
Provide a short and direct response. 0.76. What is the ratio of the Bank branche(per 100,000 adults) in Brunei Darussalam in 2008 to that in 2012?
Ensure brevity in your answer.  1.02. What is the ratio of the Bank branche(per 100,000 adults) of Canada in 2008 to that in 2012?
Offer a terse response. 1.01. What is the ratio of the Bank branche(per 100,000 adults) of Lesotho in 2008 to that in 2012?
Provide a short and direct response. 0.68. What is the ratio of the Bank branche(per 100,000 adults) in Sierra Leone in 2008 to that in 2012?
Your answer should be very brief. 0.75. What is the ratio of the Bank branche(per 100,000 adults) in Lesotho in 2009 to that in 2010?
Make the answer very short. 0.69. What is the ratio of the Bank branche(per 100,000 adults) in Sierra Leone in 2009 to that in 2010?
Provide a succinct answer. 0.95. What is the ratio of the Bank branche(per 100,000 adults) in Brunei Darussalam in 2009 to that in 2011?
Keep it short and to the point. 1.03. What is the ratio of the Bank branche(per 100,000 adults) of Lesotho in 2009 to that in 2011?
Offer a terse response. 0.68. What is the ratio of the Bank branche(per 100,000 adults) of Sierra Leone in 2009 to that in 2011?
Keep it short and to the point. 0.92. What is the ratio of the Bank branche(per 100,000 adults) in Brunei Darussalam in 2009 to that in 2012?
Provide a succinct answer. 1.05. What is the ratio of the Bank branche(per 100,000 adults) in Lesotho in 2009 to that in 2012?
Provide a short and direct response. 0.69. What is the ratio of the Bank branche(per 100,000 adults) of Sierra Leone in 2009 to that in 2012?
Your answer should be compact. 0.91. What is the ratio of the Bank branche(per 100,000 adults) of Canada in 2010 to that in 2011?
Offer a terse response. 0.99. What is the ratio of the Bank branche(per 100,000 adults) in Lesotho in 2010 to that in 2011?
Your answer should be compact. 0.99. What is the ratio of the Bank branche(per 100,000 adults) in Sierra Leone in 2010 to that in 2011?
Keep it short and to the point. 0.97. What is the ratio of the Bank branche(per 100,000 adults) in Brunei Darussalam in 2010 to that in 2012?
Provide a short and direct response. 1.03. What is the ratio of the Bank branche(per 100,000 adults) in Canada in 2010 to that in 2012?
Your answer should be compact. 0.99. What is the ratio of the Bank branche(per 100,000 adults) in Lesotho in 2010 to that in 2012?
Your answer should be compact. 1.01. What is the ratio of the Bank branche(per 100,000 adults) in Sierra Leone in 2010 to that in 2012?
Provide a succinct answer. 0.96. What is the ratio of the Bank branche(per 100,000 adults) in Brunei Darussalam in 2011 to that in 2012?
Keep it short and to the point. 1.02. What is the ratio of the Bank branche(per 100,000 adults) of Canada in 2011 to that in 2012?
Offer a terse response. 1. What is the ratio of the Bank branche(per 100,000 adults) in Lesotho in 2011 to that in 2012?
Ensure brevity in your answer.  1.02. What is the ratio of the Bank branche(per 100,000 adults) in Sierra Leone in 2011 to that in 2012?
Your answer should be compact. 0.99. What is the difference between the highest and the second highest Bank branche(per 100,000 adults) of Brunei Darussalam?
Offer a very short reply. 0.5. What is the difference between the highest and the second highest Bank branche(per 100,000 adults) in Canada?
Your answer should be very brief. 0.06. What is the difference between the highest and the second highest Bank branche(per 100,000 adults) in Lesotho?
Offer a terse response. 0.02. What is the difference between the highest and the second highest Bank branche(per 100,000 adults) in Sierra Leone?
Provide a short and direct response. 0.02. What is the difference between the highest and the lowest Bank branche(per 100,000 adults) of Brunei Darussalam?
Make the answer very short. 1.07. What is the difference between the highest and the lowest Bank branche(per 100,000 adults) in Canada?
Offer a very short reply. 0.61. What is the difference between the highest and the lowest Bank branche(per 100,000 adults) of Lesotho?
Offer a terse response. 1.28. What is the difference between the highest and the lowest Bank branche(per 100,000 adults) in Sierra Leone?
Your answer should be compact. 1.19. 